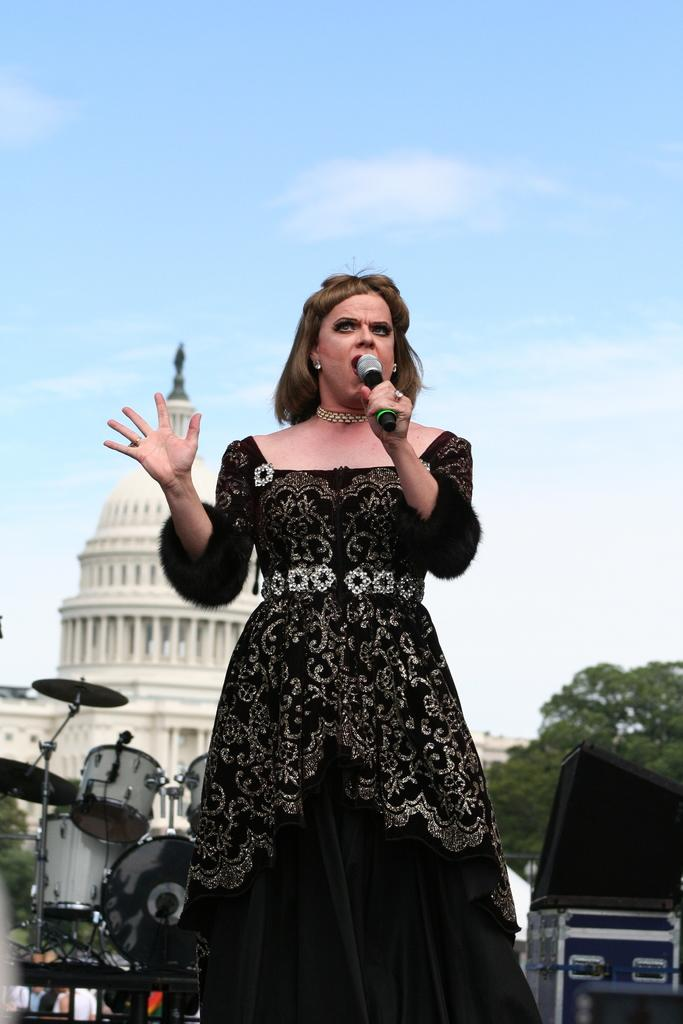Who is the main subject in the image? There is a woman in the image. What is the woman wearing? The woman is wearing a black dress. What is the woman holding in the image? The woman is holding a microphone. What musical instruments can be seen in the image? There are musical drums in the image. What type of natural environment is visible in the image? There are trees in the image. What type of man-made structures are visible in the image? There are buildings in the image. What is visible at the top of the image? The sky is visible at the top of the image. What type of feast is being prepared in the image? There is no indication of a feast being prepared in the image. How does the woman's behavior change when she sees the care provided by the trees? There is no mention of the woman's behavior or any care provided by the trees in the image. 